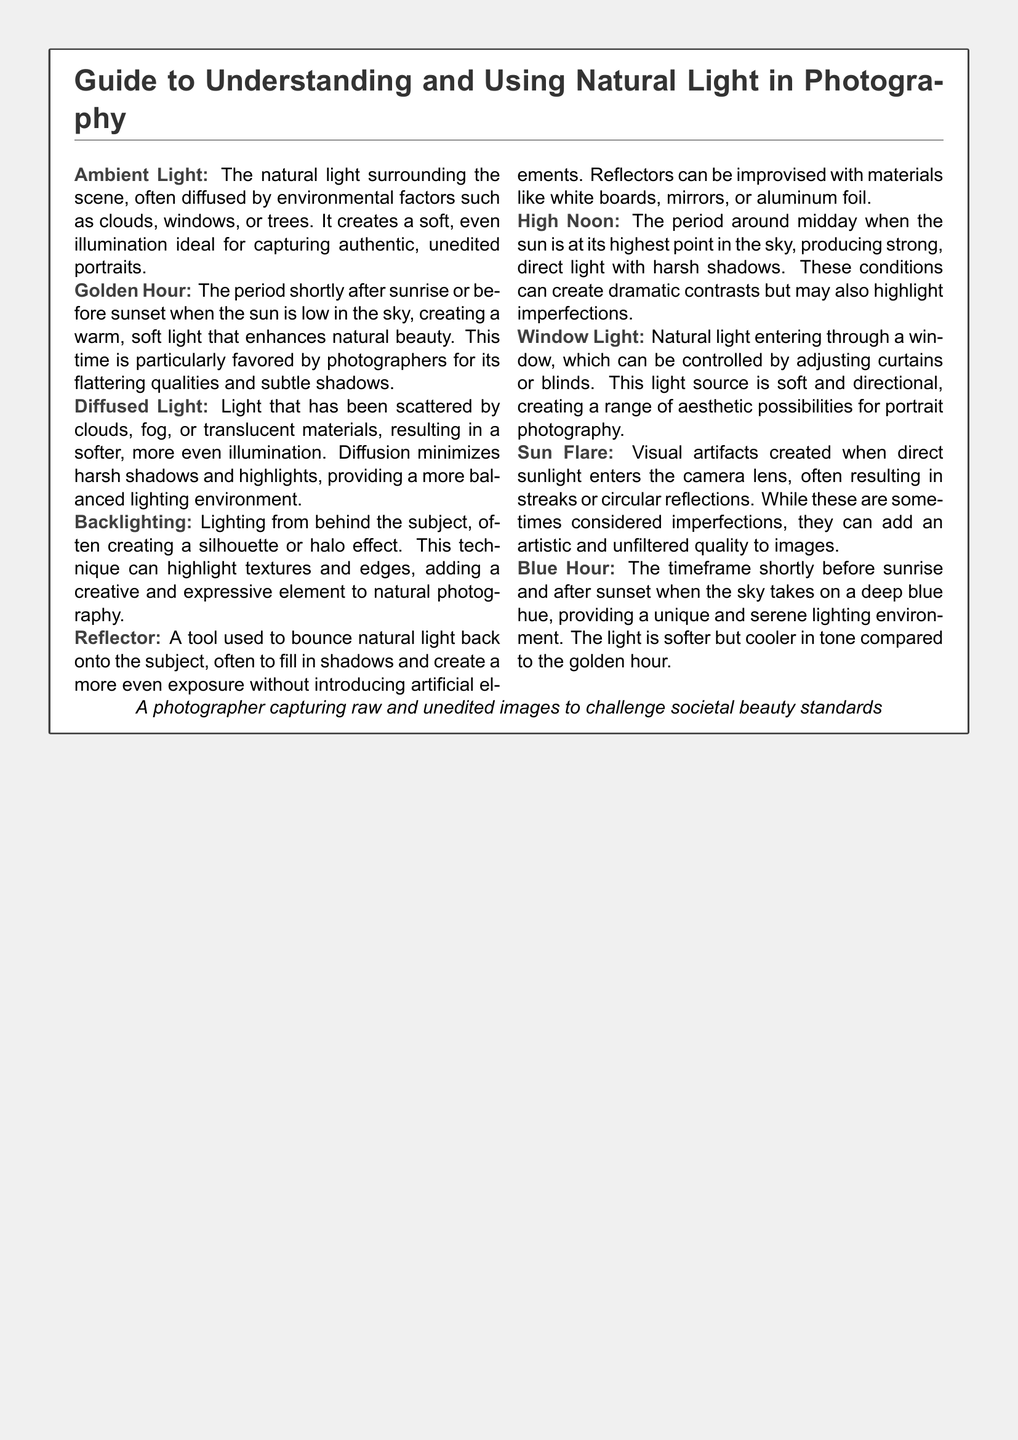What is Ambient Light? Ambient Light is defined in the glossary as the natural light surrounding the scene.
Answer: The natural light surrounding the scene What is the Golden Hour? The Golden Hour refers to the period shortly after sunrise or before sunset when the sun is low in the sky.
Answer: The period shortly after sunrise or before sunset What does Diffused Light do? Diffused Light minimizes harsh shadows and highlights, providing a balanced lighting environment.
Answer: Minimizes harsh shadows and highlights What technique uses light from behind the subject? The glossary describes Backlighting as a technique that uses light from behind the subject.
Answer: Backlighting What environment does Blue Hour provide? The document states that Blue Hour provides a unique and serene lighting environment.
Answer: Unique and serene lighting environment How can reflections be created in a photograph? The term Sun Flare describes visual artifacts created when direct sunlight enters the camera lens.
Answer: Visual artifacts created when direct sunlight enters the camera lens What does Window Light create for portrait photography? The glossary indicates that Window Light is soft and directional, creating aesthetic possibilities.
Answer: Soft and directional What is the main disadvantage of High Noon lighting? High Noon is noted for producing strong, direct light with harsh shadows, which can highlight imperfections.
Answer: Highlight imperfections What is a common use for a Reflector? The glossary states that a Reflector is commonly used to bounce natural light back onto the subject.
Answer: Bounce natural light back onto the subject 